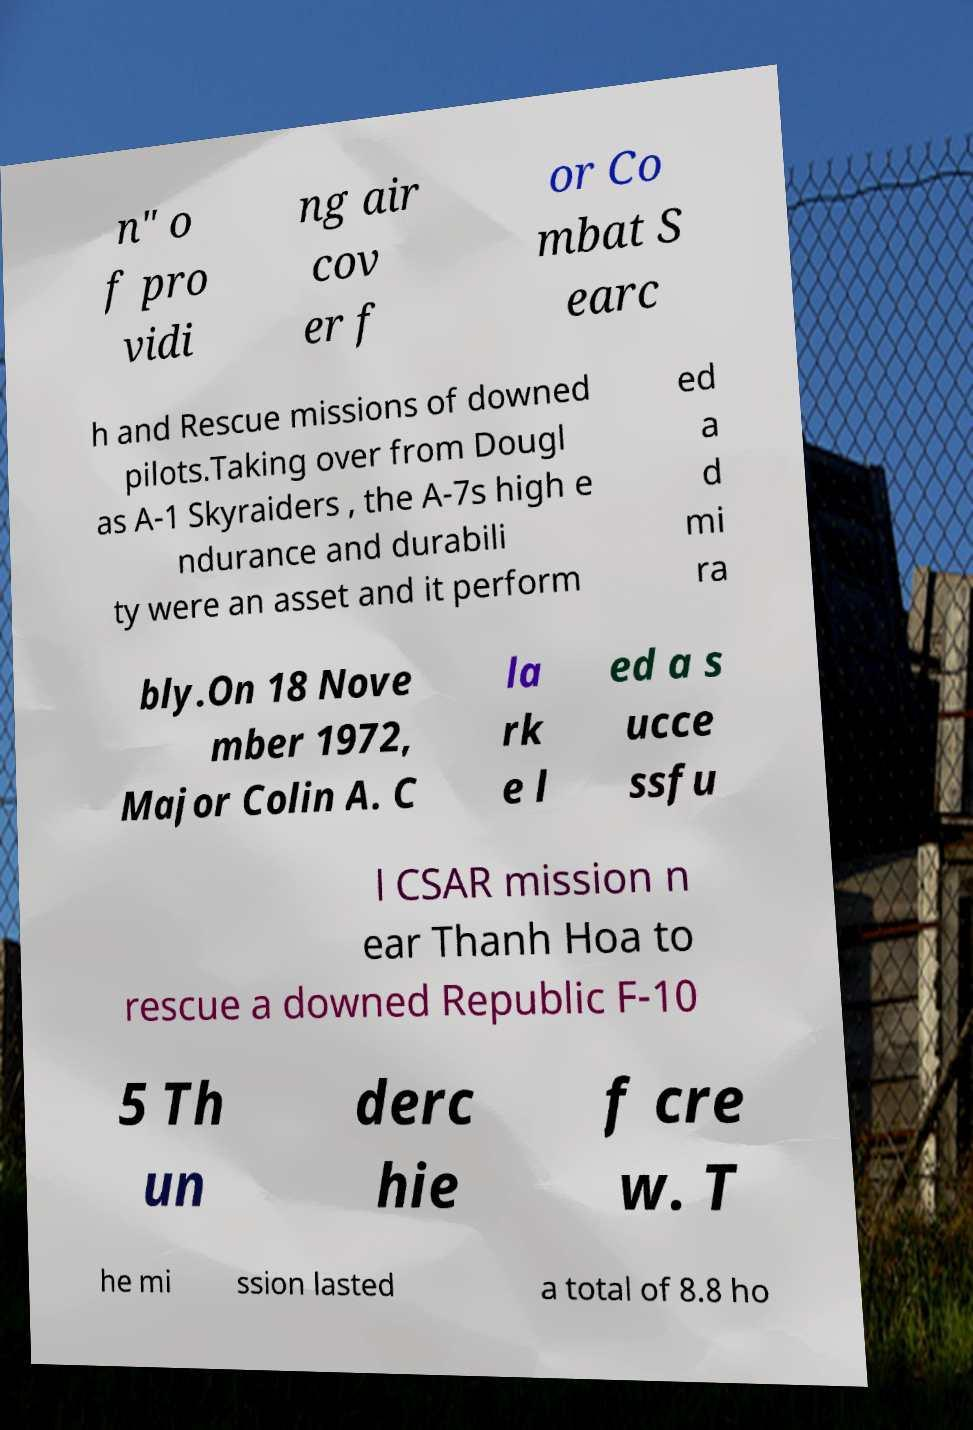What messages or text are displayed in this image? I need them in a readable, typed format. n" o f pro vidi ng air cov er f or Co mbat S earc h and Rescue missions of downed pilots.Taking over from Dougl as A-1 Skyraiders , the A-7s high e ndurance and durabili ty were an asset and it perform ed a d mi ra bly.On 18 Nove mber 1972, Major Colin A. C la rk e l ed a s ucce ssfu l CSAR mission n ear Thanh Hoa to rescue a downed Republic F-10 5 Th un derc hie f cre w. T he mi ssion lasted a total of 8.8 ho 